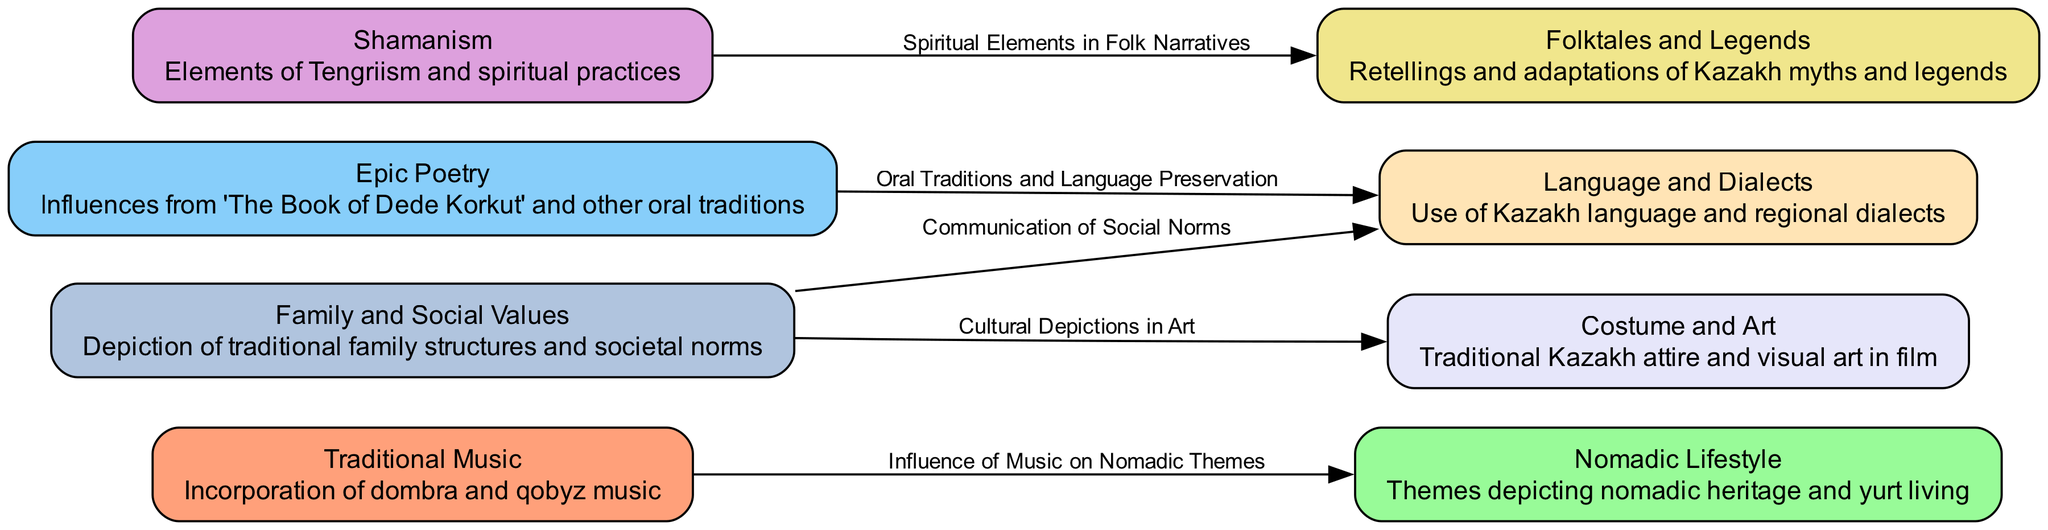What are the eight nodes in the diagram? The diagram lists eight nodes, which are "Traditional Music," "Nomadic Lifestyle," "Epic Poetry," "Shamanism," "Folktales and Legends," "Costume and Art," "Language and Dialects," and "Family and Social Values."
Answer: Eight nodes What describes the connection between Traditional Music and Nomadic Lifestyle? The edge labeled "Influence of Music on Nomadic Themes" connects these two nodes, indicating that traditional music impacts the way nomadic themes are portrayed in film narratives.
Answer: Influence of Music on Nomadic Themes How many edges are in the diagram? By counting the edges listed, there are five connections shown between the nodes in the diagram.
Answer: Five edges What influence does Epic Poetry have on Language? The edge labeled "Oral Traditions and Language Preservation" indicates that epic poetry influences the preservation of language in modern Kazakh films.
Answer: Oral Traditions and Language Preservation Which two nodes are connected by the label "Spiritual Elements in Folk Narratives"? This phrase refers to the link between "Shamanism" and "Folktales," indicating that shamanistic elements are present within the folk narratives portrayed in Kazakh films.
Answer: Shamanism and Folktales How does Family Values relate to Costume and Art? The edge indicates "Cultural Depictions in Art," which suggests that family values are reflected in the traditional attire and visual representations within the films' contexts.
Answer: Cultural Depictions in Art What connection is made between Family Values and Language? The label "Communication of Social Norms" illustrates that family values play a role in how social norms are communicated through language in the film narratives.
Answer: Communication of Social Norms Which node emphasizes themes from "The Book of Dede Korkut"? The node "Epic Poetry" emphasizes themes and influences derived from traditional oral literature, prominently including works like "The Book of Dede Korkut."
Answer: Epic Poetry 